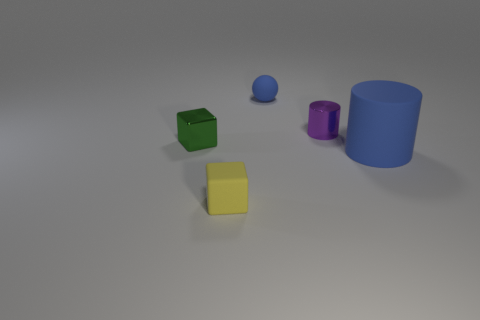Add 1 blue objects. How many objects exist? 6 Subtract all green cubes. Subtract all blue balls. How many cubes are left? 1 Subtract all cylinders. How many objects are left? 3 Subtract 1 purple cylinders. How many objects are left? 4 Subtract all big blue rubber spheres. Subtract all cylinders. How many objects are left? 3 Add 1 tiny spheres. How many tiny spheres are left? 2 Add 1 small spheres. How many small spheres exist? 2 